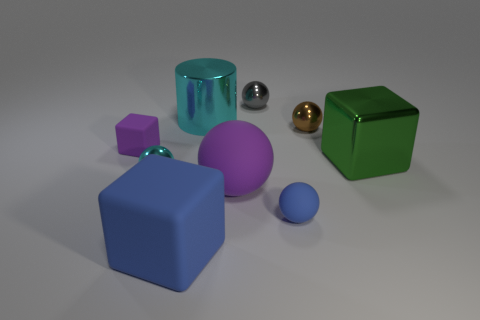Subtract all gray spheres. How many spheres are left? 4 Subtract all brown spheres. How many spheres are left? 4 Subtract all cubes. How many objects are left? 6 Add 1 matte cylinders. How many objects exist? 10 Subtract 0 red cylinders. How many objects are left? 9 Subtract 1 cylinders. How many cylinders are left? 0 Subtract all brown cylinders. Subtract all yellow spheres. How many cylinders are left? 1 Subtract all cyan balls. How many purple blocks are left? 1 Subtract all big yellow cylinders. Subtract all shiny balls. How many objects are left? 6 Add 4 rubber spheres. How many rubber spheres are left? 6 